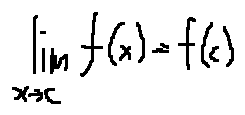Convert formula to latex. <formula><loc_0><loc_0><loc_500><loc_500>\lim \lim i t s _ { x \rightarrow c } f ( x ) = f ( c )</formula> 